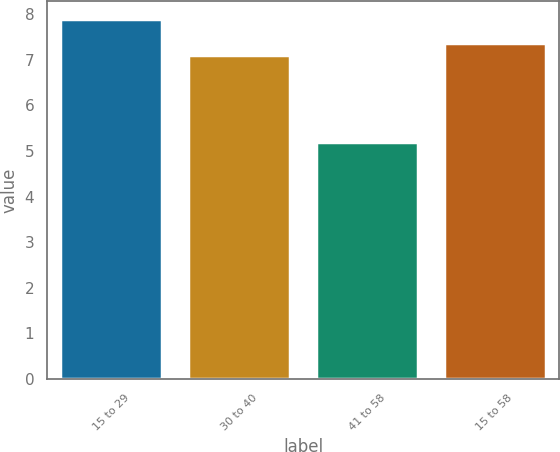<chart> <loc_0><loc_0><loc_500><loc_500><bar_chart><fcel>15 to 29<fcel>30 to 40<fcel>41 to 58<fcel>15 to 58<nl><fcel>7.9<fcel>7.1<fcel>5.2<fcel>7.37<nl></chart> 